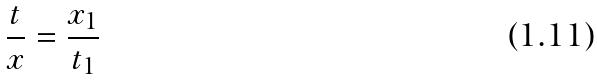Convert formula to latex. <formula><loc_0><loc_0><loc_500><loc_500>\frac { t } { x } = \frac { x _ { 1 } } { t _ { 1 } }</formula> 